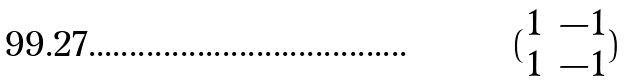Convert formula to latex. <formula><loc_0><loc_0><loc_500><loc_500>( \begin{matrix} 1 & - 1 \\ 1 & - 1 \end{matrix} )</formula> 